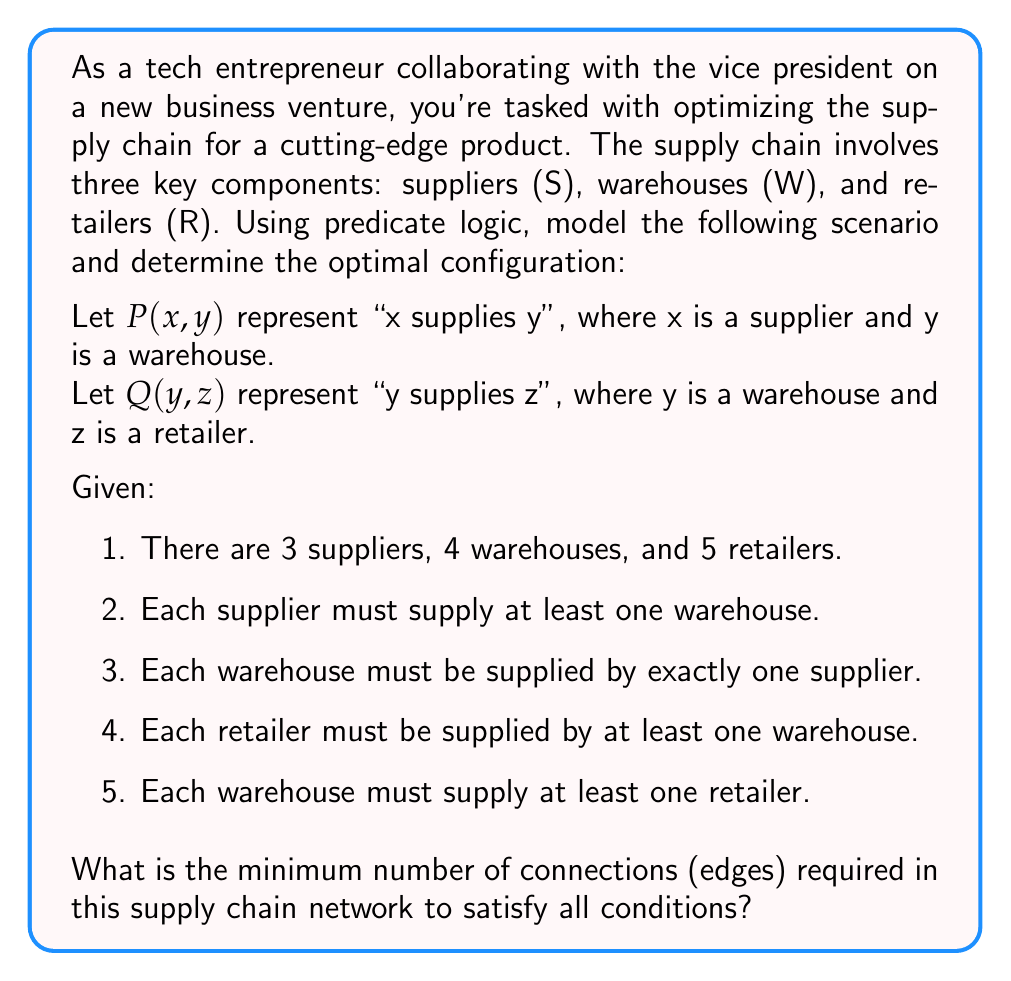Provide a solution to this math problem. Let's approach this step-by-step using predicate logic and graph theory:

1. First, let's define our sets:
   S = {$s_1$, $s_2$, $s_3$} (suppliers)
   W = {$w_1$, $w_2$, $w_3$, $w_4$} (warehouses)
   R = {$r_1$, $r_2$, $r_3$, $r_4$, $r_5$} (retailers)

2. Now, let's express the conditions using predicate logic:

   a. Each supplier must supply at least one warehouse:
      $$\forall s \in S, \exists w \in W : P(s,w)$$

   b. Each warehouse must be supplied by exactly one supplier:
      $$\forall w \in W, \exists! s \in S : P(s,w)$$

   c. Each retailer must be supplied by at least one warehouse:
      $$\forall r \in R, \exists w \in W : Q(w,r)$$

   d. Each warehouse must supply at least one retailer:
      $$\forall w \in W, \exists r \in R : Q(w,r)$$

3. To minimize the number of connections, we need to satisfy these conditions with the least number of edges:

   a. For suppliers to warehouses:
      - We need exactly 4 edges (one for each warehouse, satisfying condition b)
      - This also satisfies condition a, as each supplier will supply at least one warehouse

   b. For warehouses to retailers:
      - We need at least 5 edges (one for each retailer, satisfying condition c)
      - This also satisfies condition d, as each warehouse will supply at least one retailer

4. Therefore, the minimum number of connections is:
   4 (supplier to warehouse) + 5 (warehouse to retailer) = 9 connections

This configuration ensures that all conditions are met with the minimum number of edges in the supply chain network.
Answer: The minimum number of connections required in the supply chain network to satisfy all conditions is 9. 